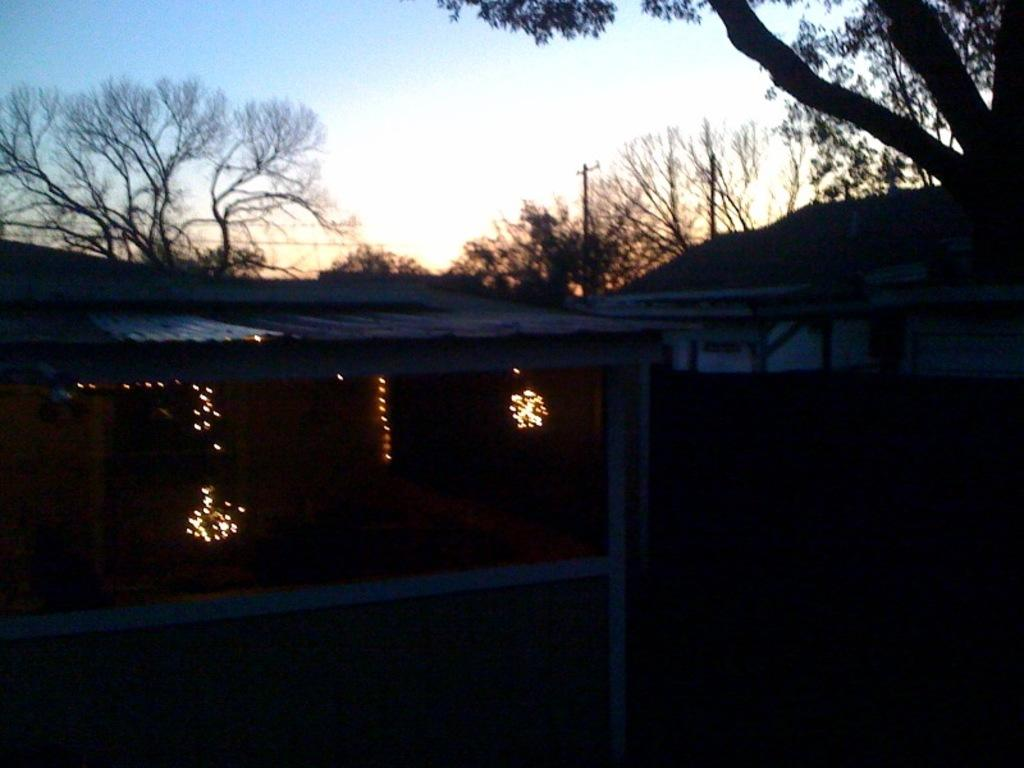What natural phenomenon can be seen in the image? There are lightnings in the image. What type of vegetation is visible in the background of the image? There are trees in the background of the image. What type of eggs can be seen in the image? There are no eggs present in the image; it features lightnings and trees. What kind of band is performing in the image? There is no band present in the image; it only shows lightnings and trees. 